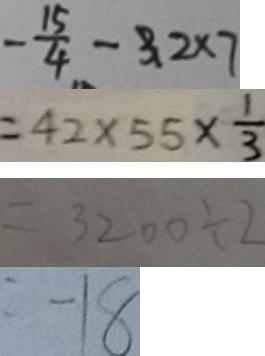Convert formula to latex. <formula><loc_0><loc_0><loc_500><loc_500>- \frac { 1 5 } { 4 } - 3 2 \times 7 
 = 4 2 \times 5 5 \times \frac { 1 } { 3 } 
 = 3 2 0 0 \div 2 
 = - 1 8</formula> 